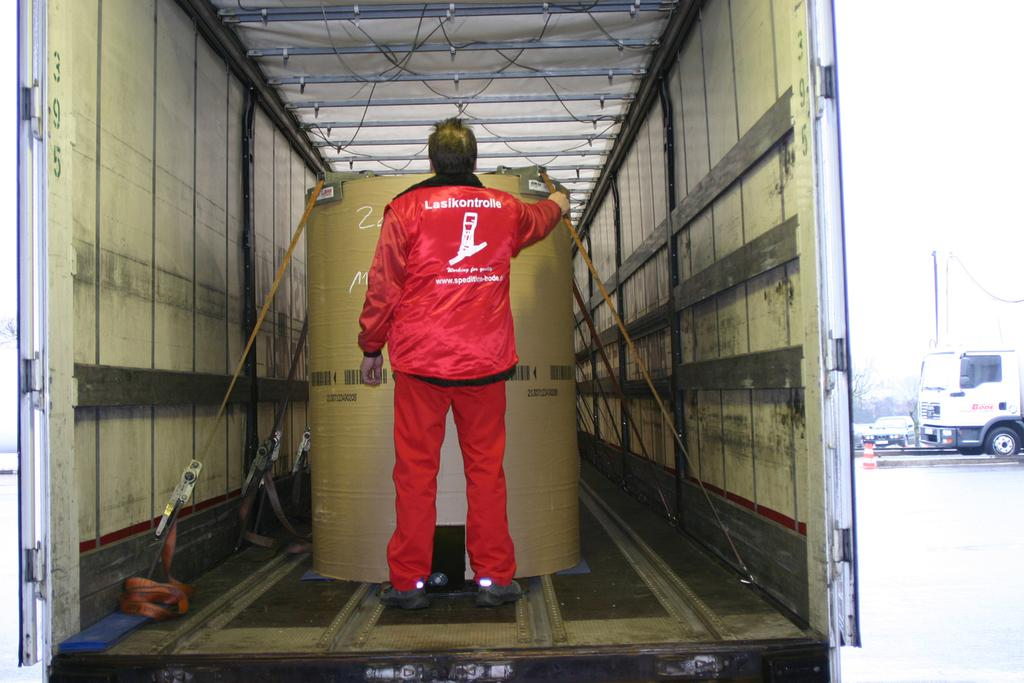What is the person in the image doing? The person is holding a drum. Where is the person located in the image? The person is inside a truck. What else can be seen on the road in the image? There are vehicles visible on the road. What type of stove can be seen in the image? There is no stove present in the image. 